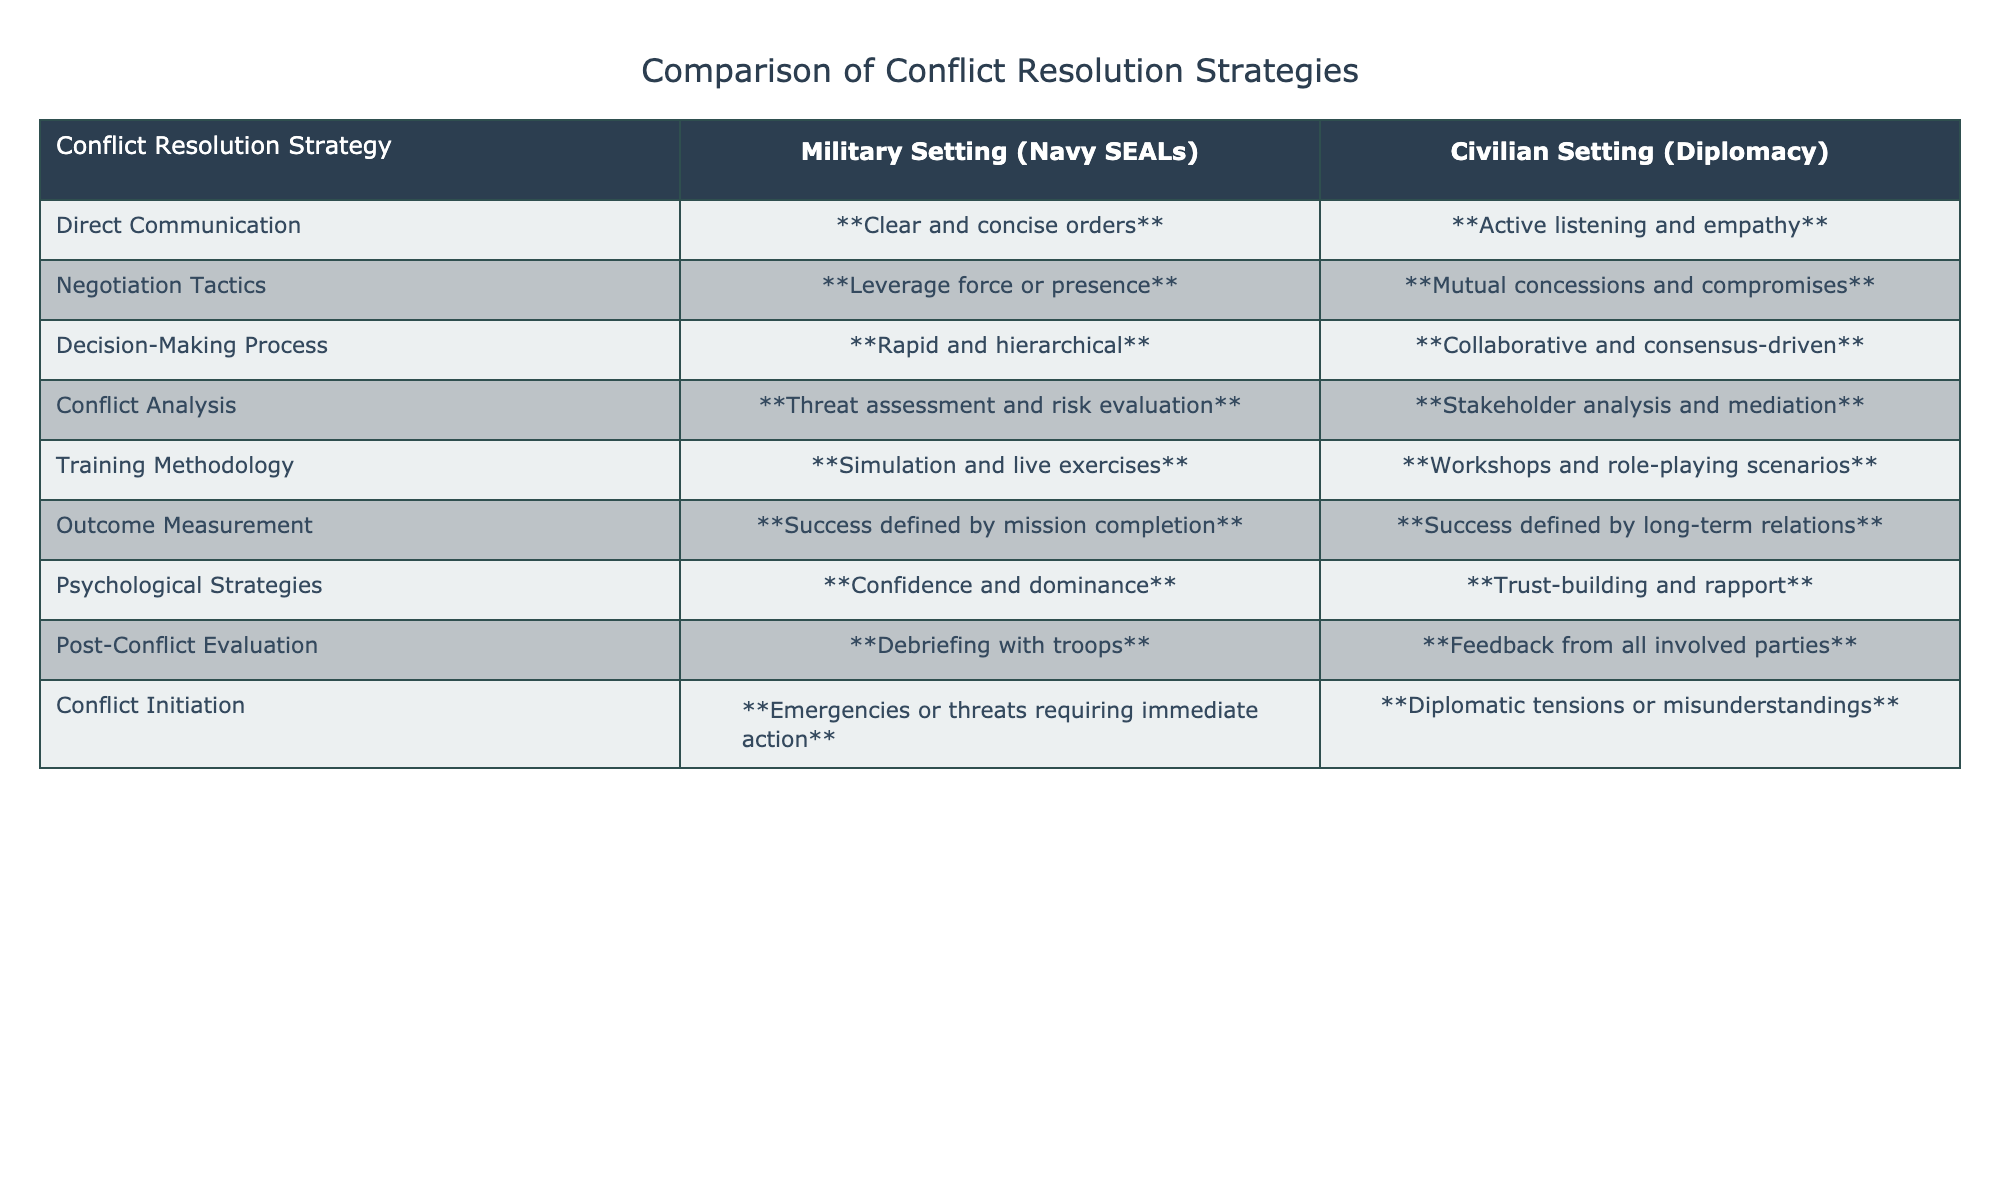What is the conflict resolution strategy for decision-making in military settings? According to the table, the conflict resolution strategy for decision-making in military settings is noted as "**Rapid and hierarchical**."
Answer: Rapid and hierarchical What is the main focus of outcome measurement in civilian settings? The table indicates that in civilian settings, the outcome measurement focuses on "**Success defined by long-term relations**."
Answer: Success defined by long-term relations Is "active listening and empathy" a strategy used in military settings? Based on the table, "active listening and empathy" is listed under civilian settings, not military settings, indicating that it is not a strategy used in military settings.
Answer: No Which approach is used for conflict analysis in civilian settings? The table shows that civilian settings utilize "**Stakeholder analysis and mediation**" for conflict analysis.
Answer: Stakeholder analysis and mediation In what ways do the military and civilian settings differ in terms of negotiation tactics? The military tactics are based on "**Leverage force or presence**," while civilian tactics focus on "**Mutual concessions and compromises**," highlighting a significant difference in approach.
Answer: Leverage force or presence vs. Mutual concessions and compromises What is the psychological strategy used in military settings, according to the table? The table states that the psychological strategy used in military settings is "**Confidence and dominance**."
Answer: Confidence and dominance Compare the training methodologies used in military versus civilian settings. Military training methodologies involve "**Simulation and live exercises**," while civilian training uses "**Workshops and role-playing scenarios**," indicating a difference in practical versus theoretical training.
Answer: Simulation and live exercises vs. Workshops and role-playing scenarios What type of conflict initiation is common in military settings? The table indicates that conflict in military settings commonly initiates from "**Emergencies or threats requiring immediate action**."
Answer: Emergencies or threats requiring immediate action Which conflict resolution strategy involves risk evaluation in the military? The military setting utilizes a conflict analysis strategy based on "**Threat assessment and risk evaluation**."
Answer: Threat assessment and risk evaluation How does the decision-making process differ between military and civilian settings? In military settings, the decision-making process is "**Rapid and hierarchical**," while in civilian contexts, it is "**Collaborative and consensus-driven**," reflecting differing operational dynamics.
Answer: Rapid and hierarchical vs. Collaborative and consensus-driven 